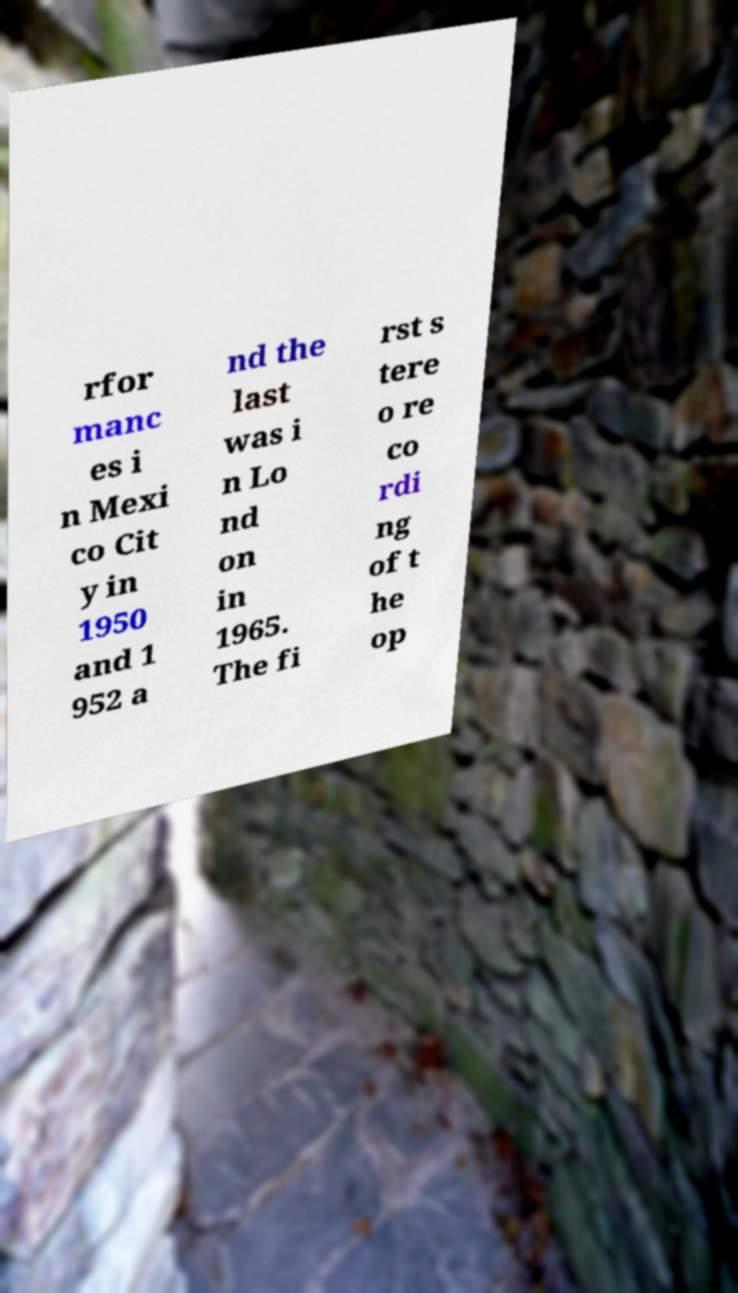Can you accurately transcribe the text from the provided image for me? rfor manc es i n Mexi co Cit y in 1950 and 1 952 a nd the last was i n Lo nd on in 1965. The fi rst s tere o re co rdi ng of t he op 